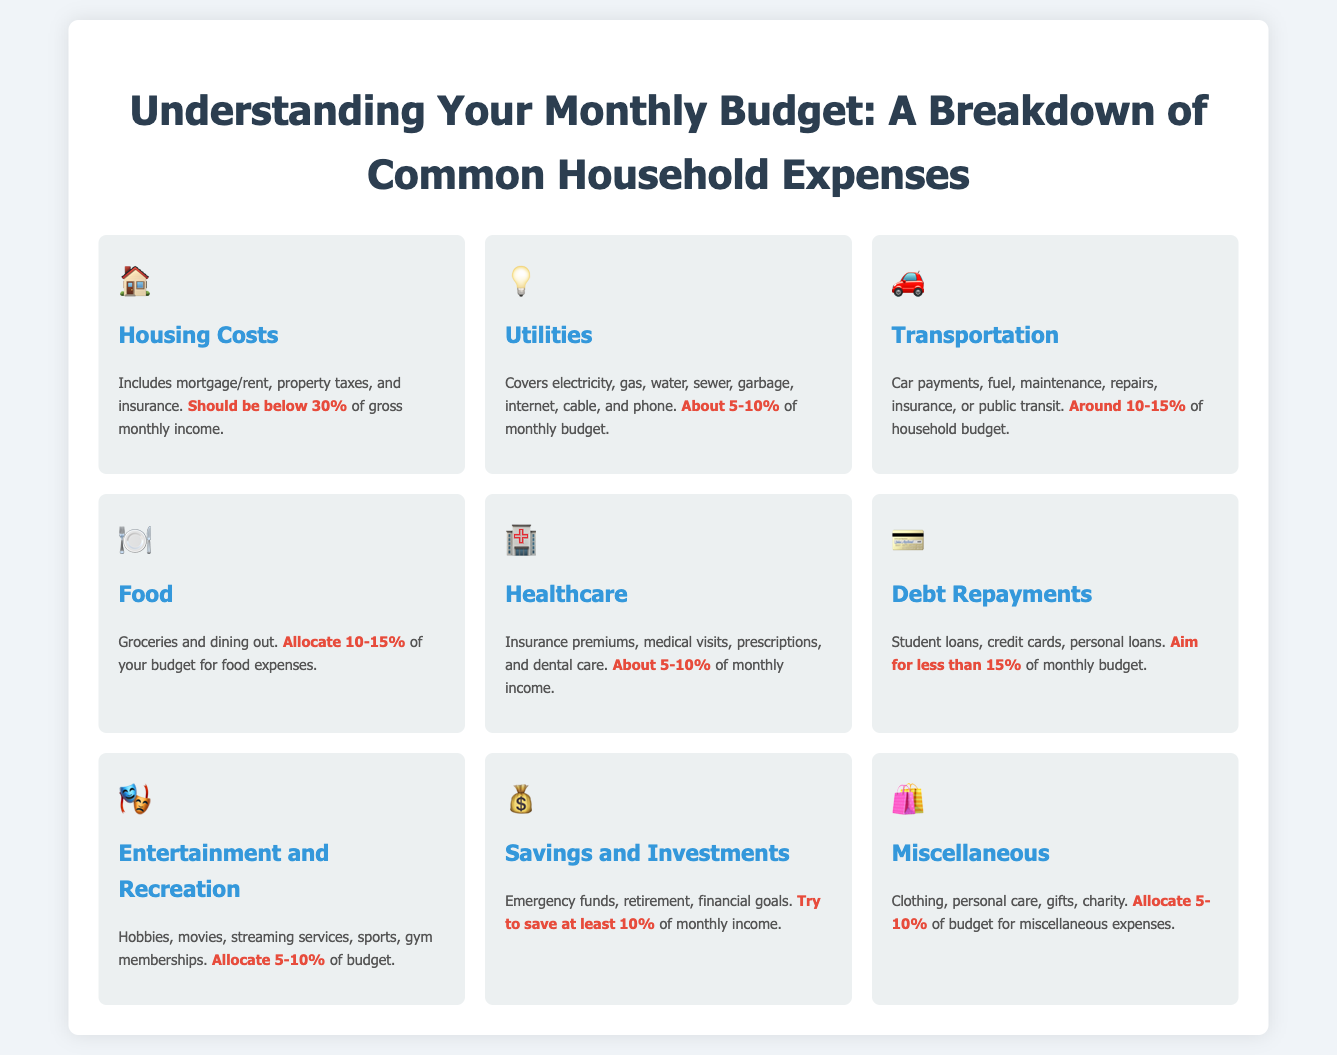what percentage should housing costs be below? Housing costs should be below 30% of gross monthly income as stated in the document.
Answer: below 30% what is the percentage range for utilities in the monthly budget? The percentage range for utilities is stated as about 5-10% of the monthly budget.
Answer: about 5-10% how much should you allocate for food expenses? The document suggests allocating 10-15% of your budget for food expenses.
Answer: 10-15% what type of expenses fall under miscellaneous? Miscellaneous expenses include clothing, personal care, gifts, and charity as mentioned in the infographic.
Answer: clothing, personal care, gifts, charity which category recommends saving at least 10%? The category that recommends saving at least 10% is Savings and Investments.
Answer: Savings and Investments what does the transportation category include? The transportation category includes car payments, fuel, maintenance, repairs, insurance, or public transit.
Answer: car payments, fuel, maintenance, repairs, insurance, public transit what is the suggested limit for debt repayments? The document recommends aiming for less than 15% of the monthly budget for debt repayments.
Answer: less than 15% how are entertainment and recreation expenses described? Entertainment and recreation expenses include hobbies, movies, streaming services, sports, and gym memberships, as detailed in the document.
Answer: hobbies, movies, streaming services, sports, gym memberships what does the card for healthcare cover? The healthcare card covers insurance premiums, medical visits, prescriptions, and dental care according to the infographic.
Answer: insurance premiums, medical visits, prescriptions, dental care 